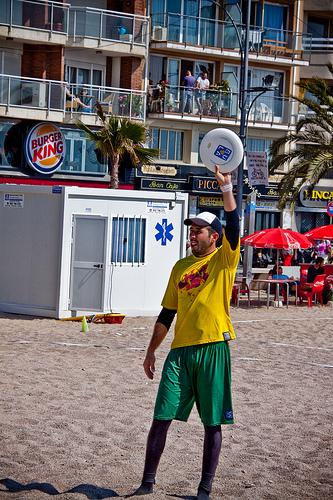Question: what is the man holding?
Choices:
A. Doll.
B. Book.
C. Cat.
D. Frisbee.
Answer with the letter. Answer: D Question: what color is the man's shirt?
Choices:
A. Yellow.
B. Red.
C. White.
D. Black.
Answer with the letter. Answer: A Question: what food sign is in the background?
Choices:
A. Burger King.
B. McDonalds.
C. Dunkin Donuts.
D. Arby's.
Answer with the letter. Answer: A Question: where is the man at?
Choices:
A. Mall.
B. Park.
C. Store.
D. Beach hotel.
Answer with the letter. Answer: D Question: how many people are with the man?
Choices:
A. One.
B. Two.
C. Three.
D. None.
Answer with the letter. Answer: D Question: what color is the umbrella?
Choices:
A. Red.
B. Orange.
C. Yellow.
D. Pink.
Answer with the letter. Answer: A Question: what is on the ground?
Choices:
A. Dirt.
B. Mud.
C. Sand.
D. Water.
Answer with the letter. Answer: C 